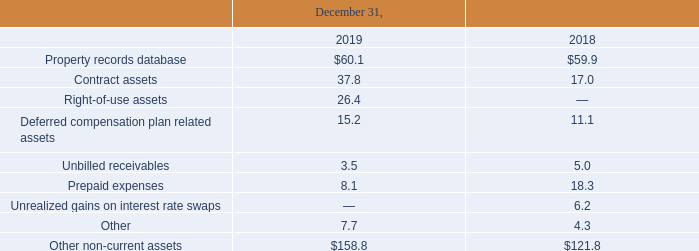(11) Other Non-Current Assets
Other non-current assets consist of the following (in millions):
Which years does the table provide information for other non-current assets of the company? 2019, 2018. What were the amount of contract assets in 2019?
Answer scale should be: million. 37.8. What was the amount of right-of-use assets in 2019?
Answer scale should be: million. 26.4. What was the change in prepaid expenses between 2018 and 2019?
Answer scale should be: million. 8.1-18.3
Answer: -10.2. What was the change in unbilled receivables between 2018 and 2019?
Answer scale should be: million. 3.5-5.0
Answer: -1.5. What was the percentage change in the total other non-current assets between 2018 and 2019?
Answer scale should be: percent. (158.8-121.8)/121.8
Answer: 30.38. 